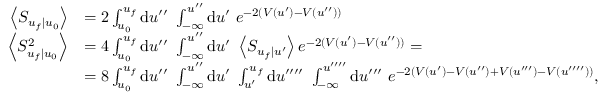<formula> <loc_0><loc_0><loc_500><loc_500>\begin{array} { r l } { \left \langle S _ { u _ { f } | u _ { 0 } } \right \rangle } & { = 2 \int _ { u _ { 0 } } ^ { u _ { f } } d u ^ { \prime \prime } \ \int _ { - \infty } ^ { u ^ { \prime \prime } } d u ^ { \prime } \ e ^ { - 2 ( V ( u ^ { \prime } ) - V ( u ^ { \prime \prime } ) ) } } \\ { \left \langle S _ { u _ { f } | u _ { 0 } } ^ { 2 } \right \rangle } & { = 4 \int _ { u _ { 0 } } ^ { u _ { f } } d u ^ { \prime \prime } \ \int _ { - \infty } ^ { u ^ { \prime \prime } } d u ^ { \prime } \ \left \langle S _ { u _ { f } | u ^ { \prime } } \right \rangle e ^ { - 2 ( V ( u ^ { \prime } ) - V ( u ^ { \prime \prime } ) ) } = } \\ & { = 8 \int _ { u _ { 0 } } ^ { u _ { f } } d u ^ { \prime \prime } \ \int _ { - \infty } ^ { u ^ { \prime \prime } } d u ^ { \prime } \ \int _ { u ^ { \prime } } ^ { u _ { f } } d u ^ { \prime \prime \prime \prime } \ \int _ { - \infty } ^ { u ^ { \prime \prime \prime \prime } } d u ^ { \prime \prime \prime } \ e ^ { - 2 ( V ( u ^ { \prime } ) - V ( u ^ { \prime \prime } ) + V ( u ^ { \prime \prime \prime } ) - V ( u ^ { \prime \prime \prime \prime } ) ) } , } \end{array}</formula> 